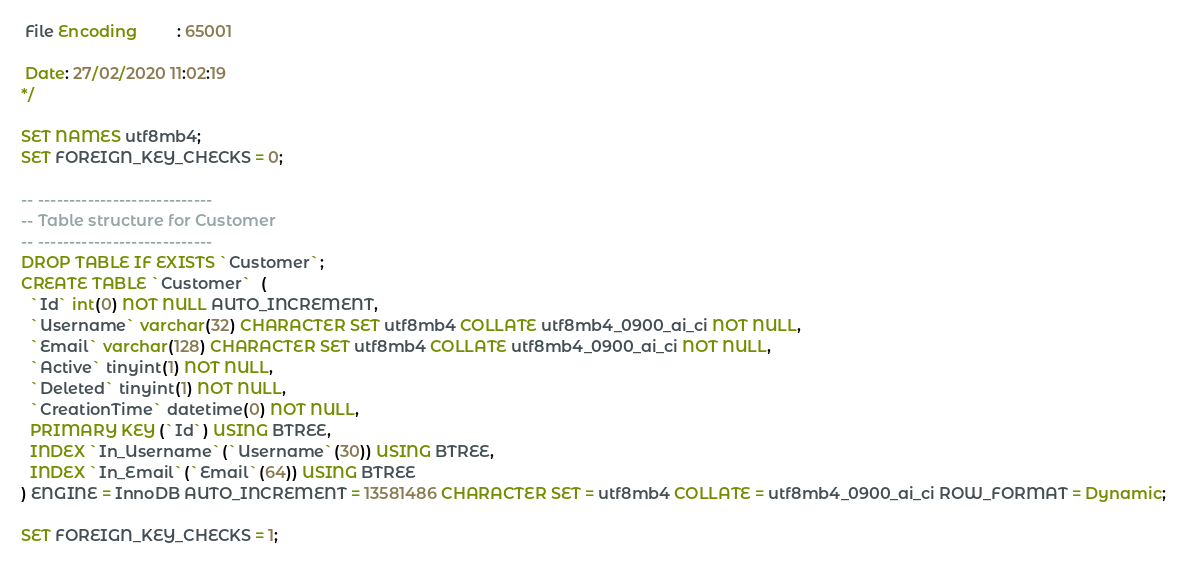Convert code to text. <code><loc_0><loc_0><loc_500><loc_500><_SQL_> File Encoding         : 65001

 Date: 27/02/2020 11:02:19
*/

SET NAMES utf8mb4;
SET FOREIGN_KEY_CHECKS = 0;

-- ----------------------------
-- Table structure for Customer
-- ----------------------------
DROP TABLE IF EXISTS `Customer`;
CREATE TABLE `Customer`  (
  `Id` int(0) NOT NULL AUTO_INCREMENT,
  `Username` varchar(32) CHARACTER SET utf8mb4 COLLATE utf8mb4_0900_ai_ci NOT NULL,
  `Email` varchar(128) CHARACTER SET utf8mb4 COLLATE utf8mb4_0900_ai_ci NOT NULL,
  `Active` tinyint(1) NOT NULL,
  `Deleted` tinyint(1) NOT NULL,
  `CreationTime` datetime(0) NOT NULL,
  PRIMARY KEY (`Id`) USING BTREE,
  INDEX `In_Username`(`Username`(30)) USING BTREE,
  INDEX `In_Email`(`Email`(64)) USING BTREE
) ENGINE = InnoDB AUTO_INCREMENT = 13581486 CHARACTER SET = utf8mb4 COLLATE = utf8mb4_0900_ai_ci ROW_FORMAT = Dynamic;

SET FOREIGN_KEY_CHECKS = 1;
</code> 